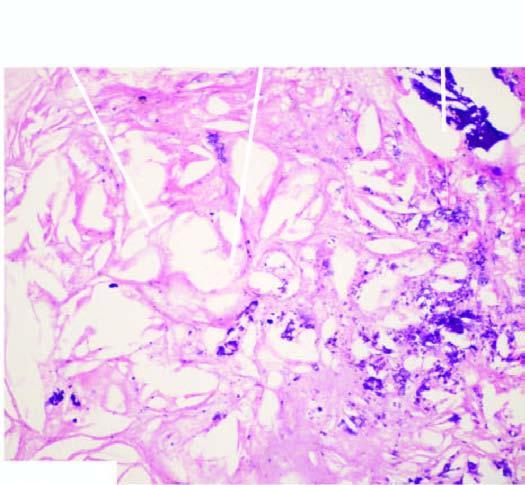s the alveolar septa narrowing of the lumen of coronary due to fully developed atheromatous plaque which has dystrophic calcification in its core?
Answer the question using a single word or phrase. No 